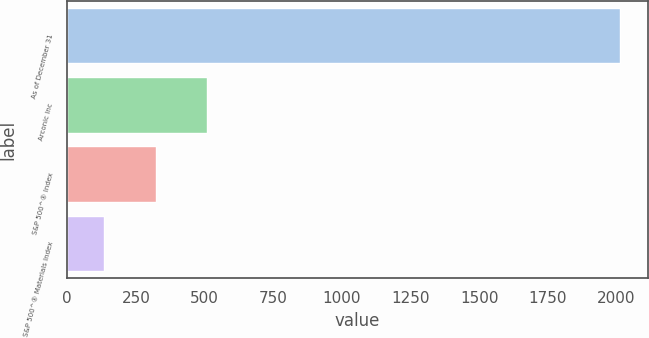Convert chart. <chart><loc_0><loc_0><loc_500><loc_500><bar_chart><fcel>As of December 31<fcel>Arconic Inc<fcel>S&P 500^® Index<fcel>S&P 500^® Materials Index<nl><fcel>2014<fcel>510.22<fcel>322.25<fcel>134.28<nl></chart> 